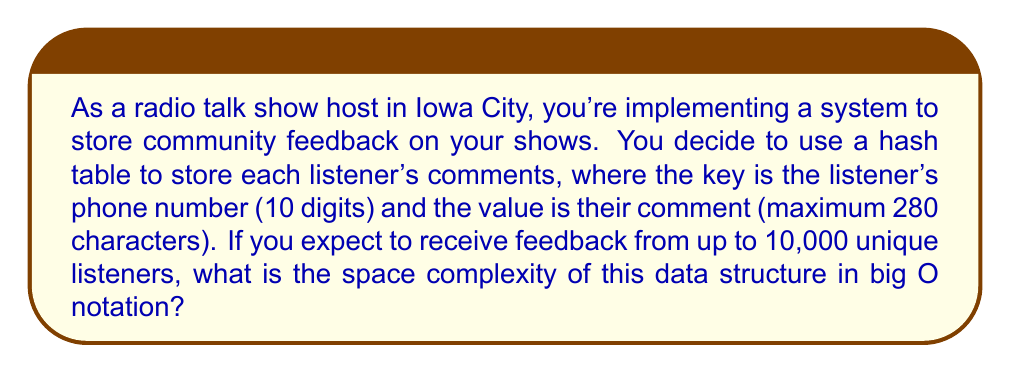What is the answer to this math problem? To determine the space complexity, let's break down the components of our data structure:

1. Hash table size:
   - We expect up to 10,000 unique listeners, so our hash table will have 10,000 entries.
   - Space required: $O(n)$, where $n$ is the number of entries (10,000).

2. Keys (phone numbers):
   - Each key is a 10-digit phone number.
   - Assuming each digit requires 1 byte, each key requires 10 bytes.
   - Total space for keys: $10 \times 10,000 = 100,000$ bytes
   - This is still $O(n)$ in relation to the number of entries.

3. Values (comments):
   - Each comment has a maximum of 280 characters.
   - Assuming each character requires 1 byte, each value requires at most 280 bytes.
   - Total space for values: $280 \times 10,000 = 2,800,000$ bytes
   - This is also $O(n)$ in relation to the number of entries.

4. Additional space for hash table implementation:
   - Most hash table implementations require some additional space for things like load factor management.
   - This is typically a constant factor of the number of entries, so it's still $O(n)$.

Combining all these components:

$$\text{Total Space} = O(n) + O(n) + O(n) + O(n) = O(n)$$

The constant factors (10 for phone numbers, 280 for comments) do not affect the big O notation, as we're concerned with the growth rate as $n$ increases.
Answer: $O(n)$, where $n$ is the number of unique listeners providing feedback. 